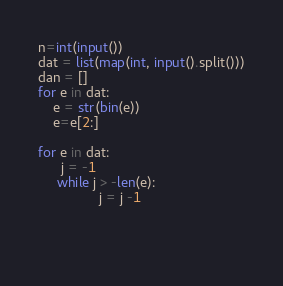<code> <loc_0><loc_0><loc_500><loc_500><_Python_>n=int(input())
dat = list(map(int, input().split()))
dan = []
for e in dat:
    e = str(bin(e))
    e=e[2:]
       
for e in dat:
      j = -1
     while j > -len(e):
                j = j -1

         
           


</code> 